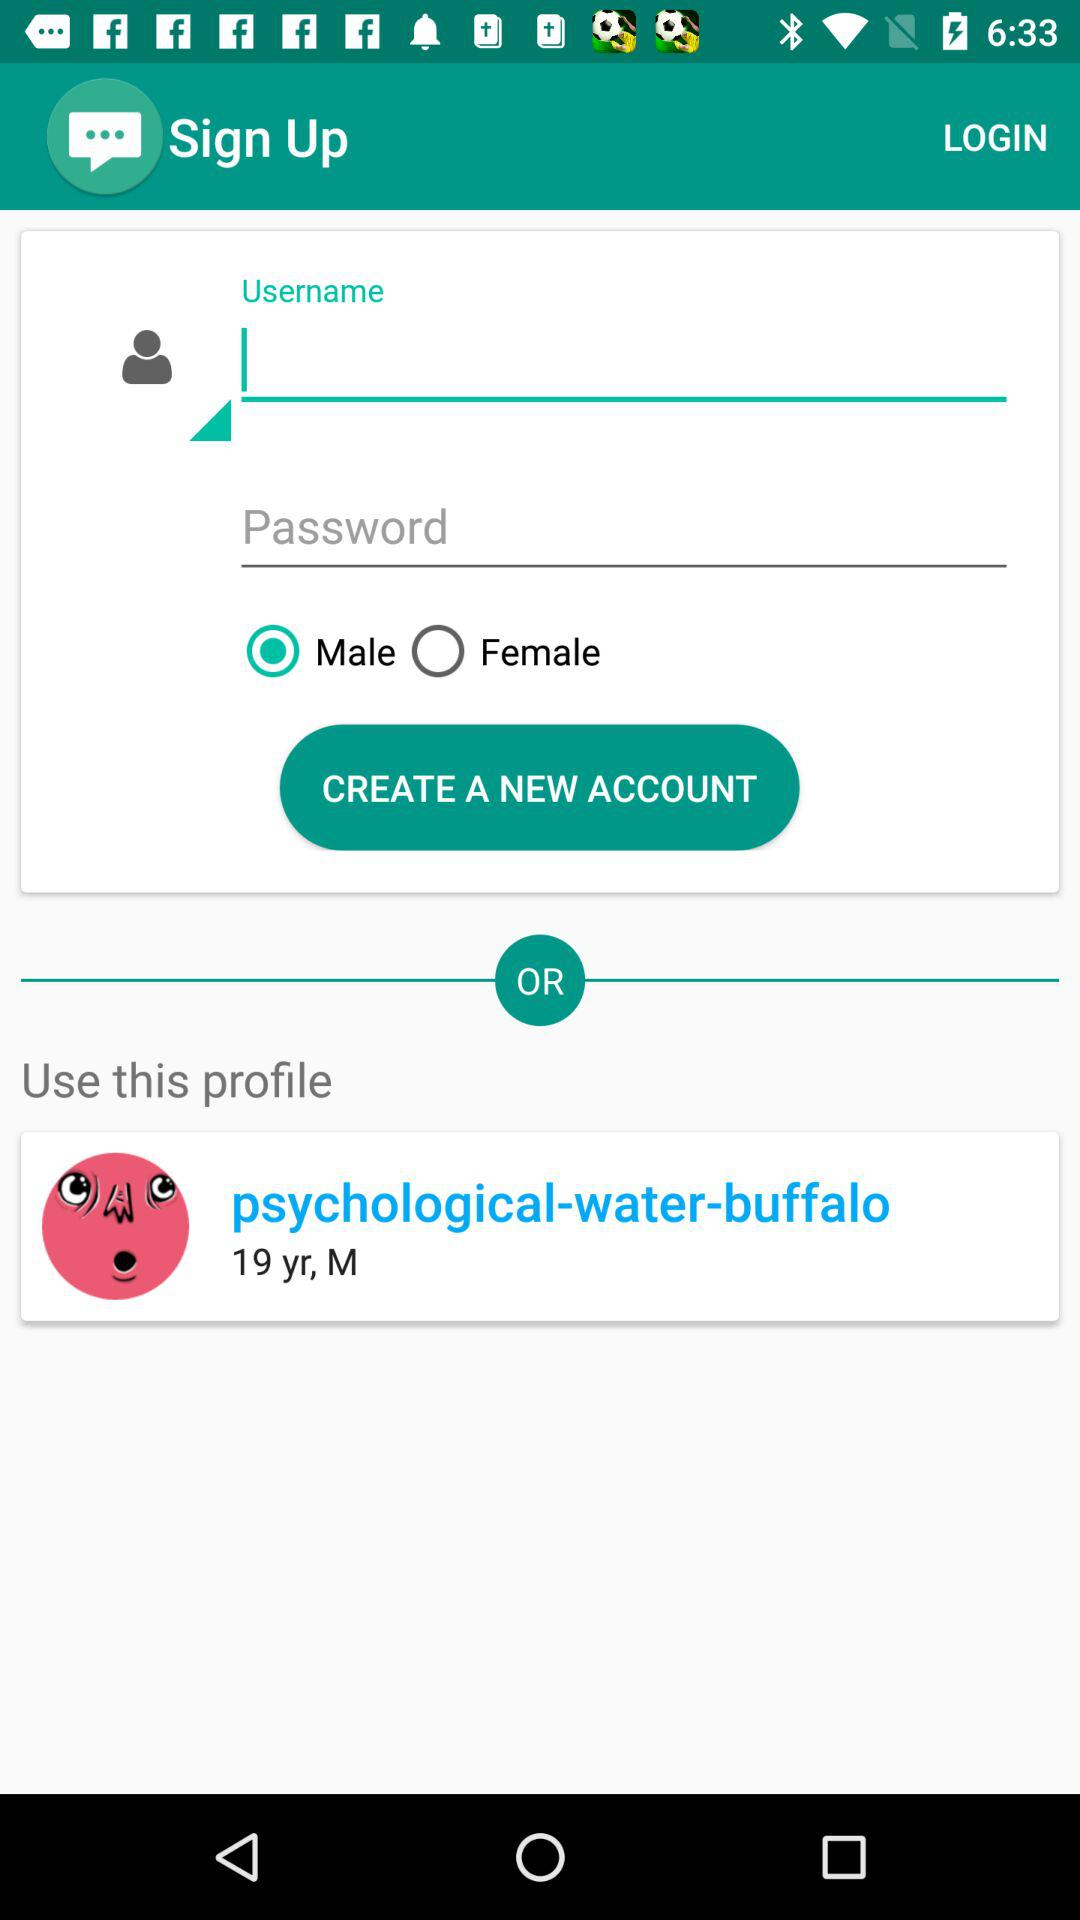What is the gender of psychological-water-buffalo? The gender is male. 